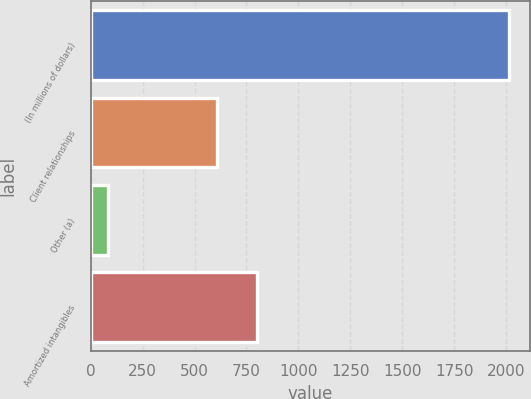<chart> <loc_0><loc_0><loc_500><loc_500><bar_chart><fcel>(In millions of dollars)<fcel>Client relationships<fcel>Other (a)<fcel>Amortized intangibles<nl><fcel>2014<fcel>609<fcel>83<fcel>802.1<nl></chart> 